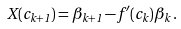<formula> <loc_0><loc_0><loc_500><loc_500>X ( c _ { k + 1 } ) = \beta _ { k + 1 } - f ^ { \prime } ( c _ { k } ) \beta _ { k } \, .</formula> 